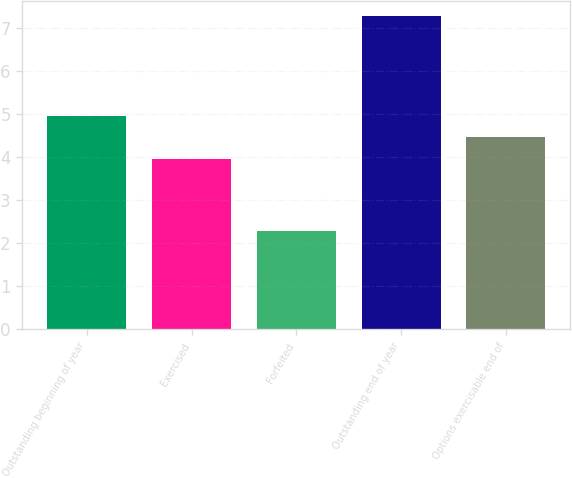<chart> <loc_0><loc_0><loc_500><loc_500><bar_chart><fcel>Outstanding beginning of year<fcel>Exercised<fcel>Forfeited<fcel>Outstanding end of year<fcel>Options exercisable end of<nl><fcel>4.96<fcel>3.96<fcel>2.27<fcel>7.26<fcel>4.46<nl></chart> 